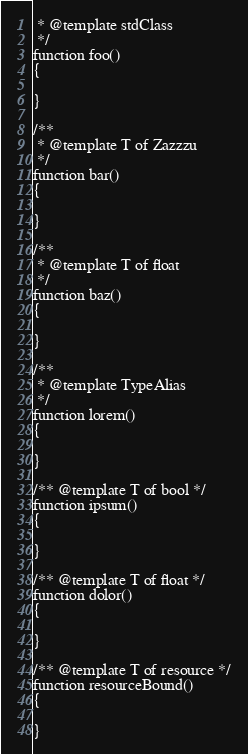Convert code to text. <code><loc_0><loc_0><loc_500><loc_500><_PHP_> * @template stdClass
 */
function foo()
{

}

/**
 * @template T of Zazzzu
 */
function bar()
{

}

/**
 * @template T of float
 */
function baz()
{

}

/**
 * @template TypeAlias
 */
function lorem()
{

}

/** @template T of bool */
function ipsum()
{

}

/** @template T of float */
function dolor()
{

}

/** @template T of resource */
function resourceBound()
{

}
</code> 